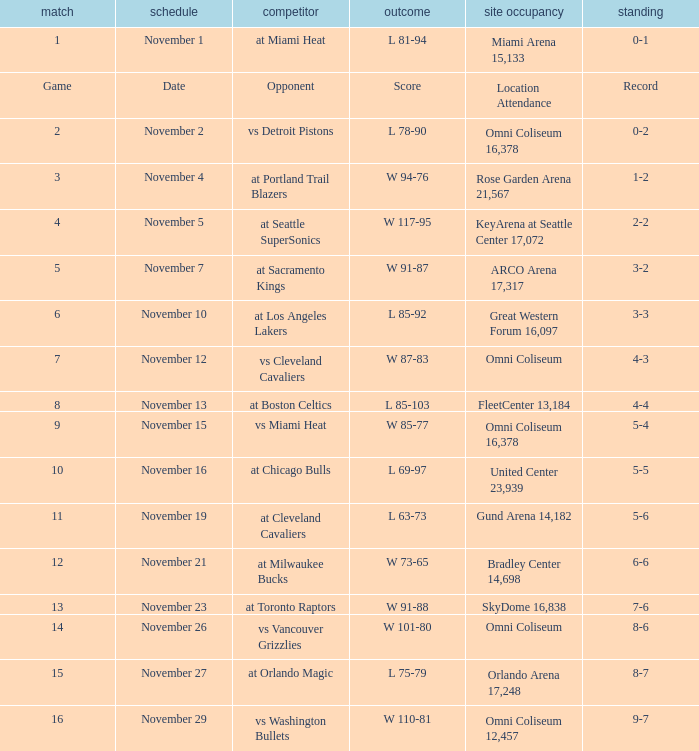Who was their opponent in game 4? At seattle supersonics. Can you parse all the data within this table? {'header': ['match', 'schedule', 'competitor', 'outcome', 'site occupancy', 'standing'], 'rows': [['1', 'November 1', 'at Miami Heat', 'L 81-94', 'Miami Arena 15,133', '0-1'], ['Game', 'Date', 'Opponent', 'Score', 'Location Attendance', 'Record'], ['2', 'November 2', 'vs Detroit Pistons', 'L 78-90', 'Omni Coliseum 16,378', '0-2'], ['3', 'November 4', 'at Portland Trail Blazers', 'W 94-76', 'Rose Garden Arena 21,567', '1-2'], ['4', 'November 5', 'at Seattle SuperSonics', 'W 117-95', 'KeyArena at Seattle Center 17,072', '2-2'], ['5', 'November 7', 'at Sacramento Kings', 'W 91-87', 'ARCO Arena 17,317', '3-2'], ['6', 'November 10', 'at Los Angeles Lakers', 'L 85-92', 'Great Western Forum 16,097', '3-3'], ['7', 'November 12', 'vs Cleveland Cavaliers', 'W 87-83', 'Omni Coliseum', '4-3'], ['8', 'November 13', 'at Boston Celtics', 'L 85-103', 'FleetCenter 13,184', '4-4'], ['9', 'November 15', 'vs Miami Heat', 'W 85-77', 'Omni Coliseum 16,378', '5-4'], ['10', 'November 16', 'at Chicago Bulls', 'L 69-97', 'United Center 23,939', '5-5'], ['11', 'November 19', 'at Cleveland Cavaliers', 'L 63-73', 'Gund Arena 14,182', '5-6'], ['12', 'November 21', 'at Milwaukee Bucks', 'W 73-65', 'Bradley Center 14,698', '6-6'], ['13', 'November 23', 'at Toronto Raptors', 'W 91-88', 'SkyDome 16,838', '7-6'], ['14', 'November 26', 'vs Vancouver Grizzlies', 'W 101-80', 'Omni Coliseum', '8-6'], ['15', 'November 27', 'at Orlando Magic', 'L 75-79', 'Orlando Arena 17,248', '8-7'], ['16', 'November 29', 'vs Washington Bullets', 'W 110-81', 'Omni Coliseum 12,457', '9-7']]} 